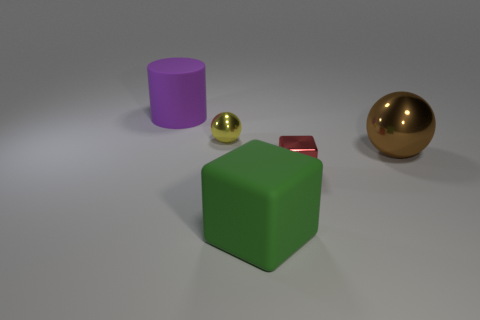Can you describe the colors and shapes of the objects in this image? Certainly! The image features geometric shapes with distinct colors: there's a large green cube, a purple cylinder, a small gold sphere, and a larger gold sphere with a reflective surface. The background is neutral and nondescript, allowing the colors of the objects to stand out. Do the objects appear to be of any particular material? Based on their appearances, the green cube looks like it might be made of a matte plastic or painted wood, while the cylinder has a smooth, possibly plastic surface. Both spheres have reflective surfaces indicative of metallic material, with the larger one having a pronounced reflective quality that suggests a polished metal. 